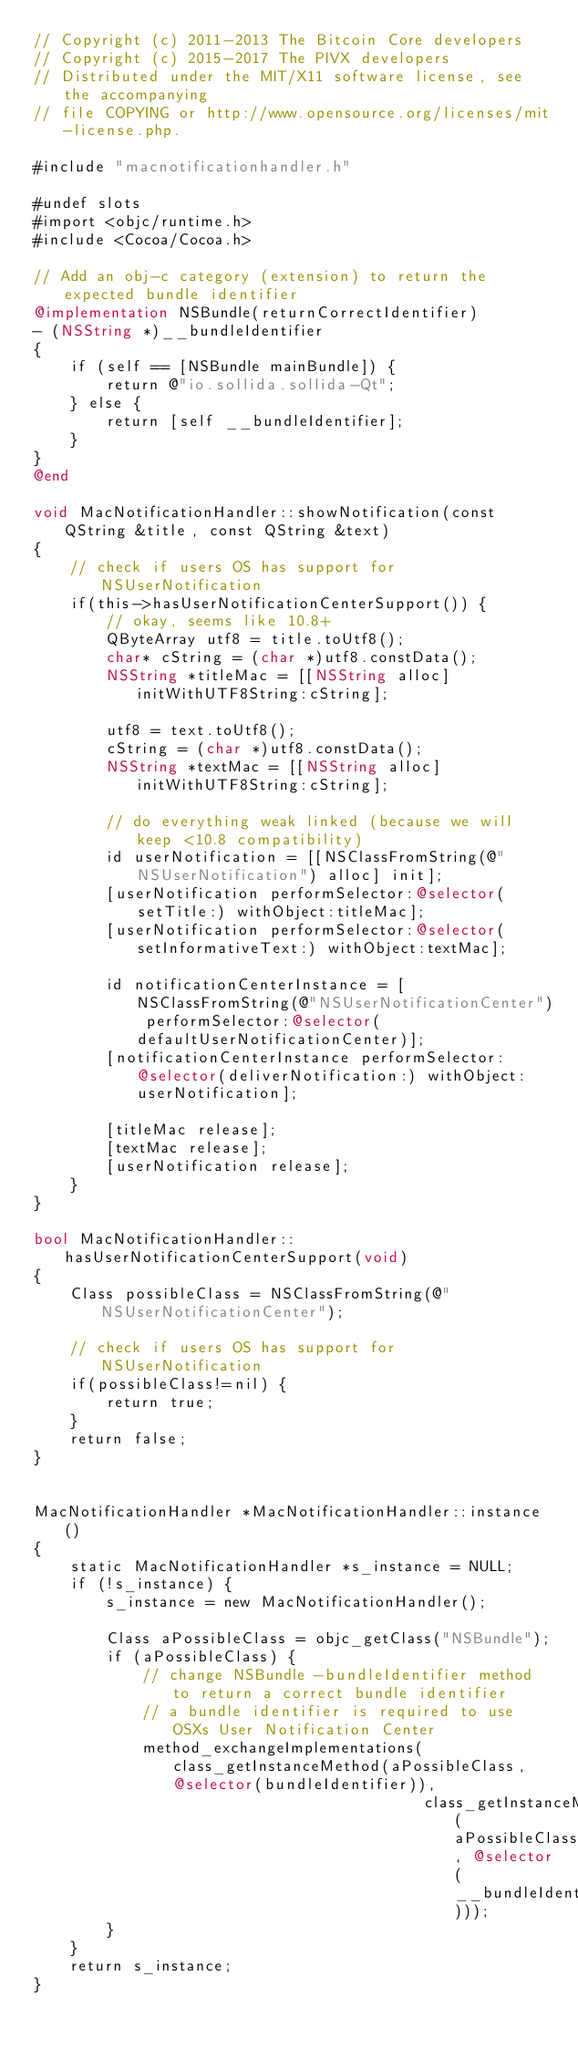<code> <loc_0><loc_0><loc_500><loc_500><_ObjectiveC_>// Copyright (c) 2011-2013 The Bitcoin Core developers
// Copyright (c) 2015-2017 The PIVX developers
// Distributed under the MIT/X11 software license, see the accompanying
// file COPYING or http://www.opensource.org/licenses/mit-license.php.

#include "macnotificationhandler.h"

#undef slots
#import <objc/runtime.h>
#include <Cocoa/Cocoa.h>

// Add an obj-c category (extension) to return the expected bundle identifier
@implementation NSBundle(returnCorrectIdentifier)
- (NSString *)__bundleIdentifier
{
    if (self == [NSBundle mainBundle]) {
        return @"io.sollida.sollida-Qt";
    } else {
        return [self __bundleIdentifier];
    }
}
@end

void MacNotificationHandler::showNotification(const QString &title, const QString &text)
{
    // check if users OS has support for NSUserNotification
    if(this->hasUserNotificationCenterSupport()) {
        // okay, seems like 10.8+
        QByteArray utf8 = title.toUtf8();
        char* cString = (char *)utf8.constData();
        NSString *titleMac = [[NSString alloc] initWithUTF8String:cString];

        utf8 = text.toUtf8();
        cString = (char *)utf8.constData();
        NSString *textMac = [[NSString alloc] initWithUTF8String:cString];

        // do everything weak linked (because we will keep <10.8 compatibility)
        id userNotification = [[NSClassFromString(@"NSUserNotification") alloc] init];
        [userNotification performSelector:@selector(setTitle:) withObject:titleMac];
        [userNotification performSelector:@selector(setInformativeText:) withObject:textMac];

        id notificationCenterInstance = [NSClassFromString(@"NSUserNotificationCenter") performSelector:@selector(defaultUserNotificationCenter)];
        [notificationCenterInstance performSelector:@selector(deliverNotification:) withObject:userNotification];

        [titleMac release];
        [textMac release];
        [userNotification release];
    }
}

bool MacNotificationHandler::hasUserNotificationCenterSupport(void)
{
    Class possibleClass = NSClassFromString(@"NSUserNotificationCenter");

    // check if users OS has support for NSUserNotification
    if(possibleClass!=nil) {
        return true;
    }
    return false;
}


MacNotificationHandler *MacNotificationHandler::instance()
{
    static MacNotificationHandler *s_instance = NULL;
    if (!s_instance) {
        s_instance = new MacNotificationHandler();
        
        Class aPossibleClass = objc_getClass("NSBundle");
        if (aPossibleClass) {
            // change NSBundle -bundleIdentifier method to return a correct bundle identifier
            // a bundle identifier is required to use OSXs User Notification Center
            method_exchangeImplementations(class_getInstanceMethod(aPossibleClass, @selector(bundleIdentifier)),
                                           class_getInstanceMethod(aPossibleClass, @selector(__bundleIdentifier)));
        }
    }
    return s_instance;
}
</code> 